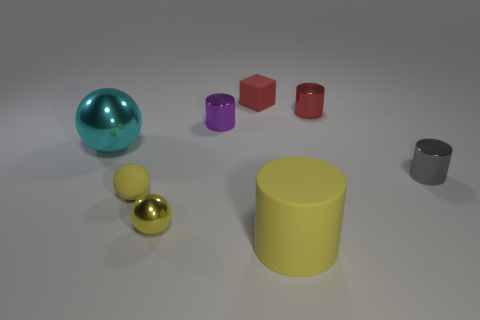Is there a tiny purple object that is in front of the cylinder in front of the metallic thing that is in front of the tiny gray metallic object?
Keep it short and to the point. No. Are there fewer large cyan metal things right of the gray object than tiny gray cylinders?
Offer a terse response. Yes. What number of other things are the same shape as the tiny red metallic thing?
Ensure brevity in your answer.  3. How many things are small rubber things that are in front of the red metallic thing or tiny red cylinders on the right side of the small cube?
Your answer should be compact. 2. What is the size of the thing that is to the right of the yellow cylinder and on the left side of the gray metallic object?
Keep it short and to the point. Small. Does the big object that is in front of the large metal ball have the same shape as the large cyan metallic object?
Keep it short and to the point. No. How big is the matte thing that is right of the rubber object that is behind the ball that is behind the gray metal cylinder?
Give a very brief answer. Large. The metal thing that is the same color as the big matte cylinder is what size?
Give a very brief answer. Small. What number of things are either tiny purple metallic things or big yellow matte cylinders?
Provide a succinct answer. 2. There is a tiny thing that is both behind the gray shiny cylinder and on the left side of the red rubber object; what is its shape?
Offer a very short reply. Cylinder. 